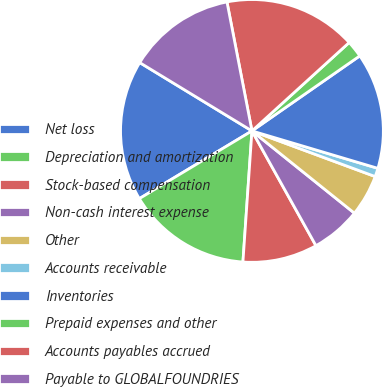<chart> <loc_0><loc_0><loc_500><loc_500><pie_chart><fcel>Net loss<fcel>Depreciation and amortization<fcel>Stock-based compensation<fcel>Non-cash interest expense<fcel>Other<fcel>Accounts receivable<fcel>Inventories<fcel>Prepaid expenses and other<fcel>Accounts payables accrued<fcel>Payable to GLOBALFOUNDRIES<nl><fcel>17.32%<fcel>15.29%<fcel>9.19%<fcel>6.14%<fcel>5.12%<fcel>1.05%<fcel>14.27%<fcel>2.07%<fcel>16.3%<fcel>13.25%<nl></chart> 